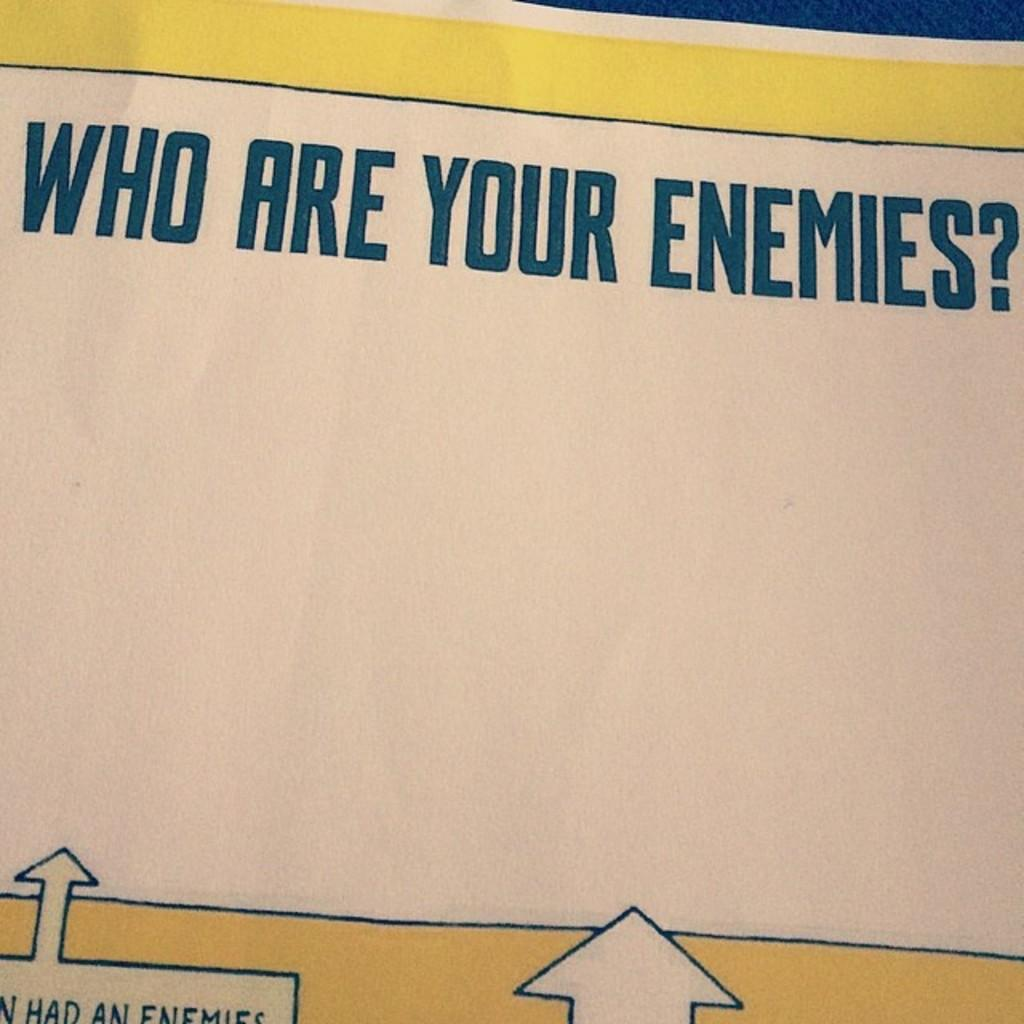<image>
Provide a brief description of the given image. A paper bordered in yellow asking "Who are your enemies?" 